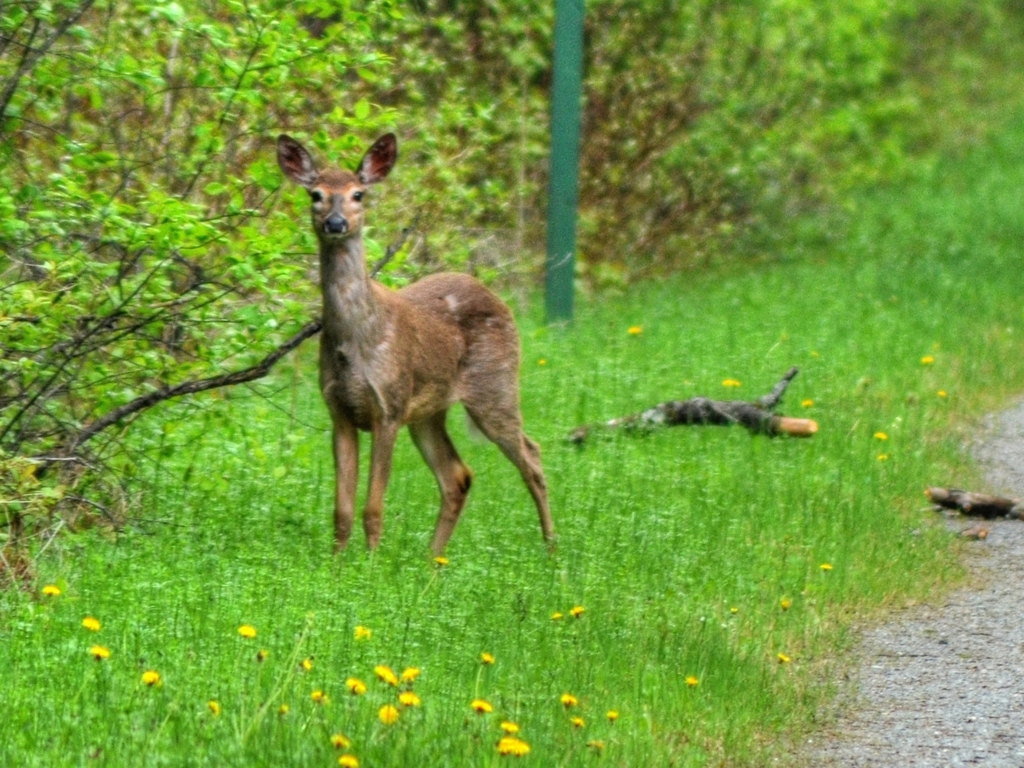Could you give some tips on how this photograph could have been improved from a photography perspective? Certainly! To improve this photograph, the photographer could use a faster shutter speed to reduce the blur caused by the deer's movement or camera shake. Using a tripod or steadying the camera on a fixed object could also help achieve a sharper image. Adjusting the ISO to a lower setting might reduce the graininess, but this has to be balanced with the available light to avoid underexposure. Compositionally, the photographer could use the rule of thirds to position the deer off-center, which often results in a more dynamic and engaging photo. Additionally, waiting for a moment when the deer is looking into the camera, as it creates a strong connection with the viewer. 